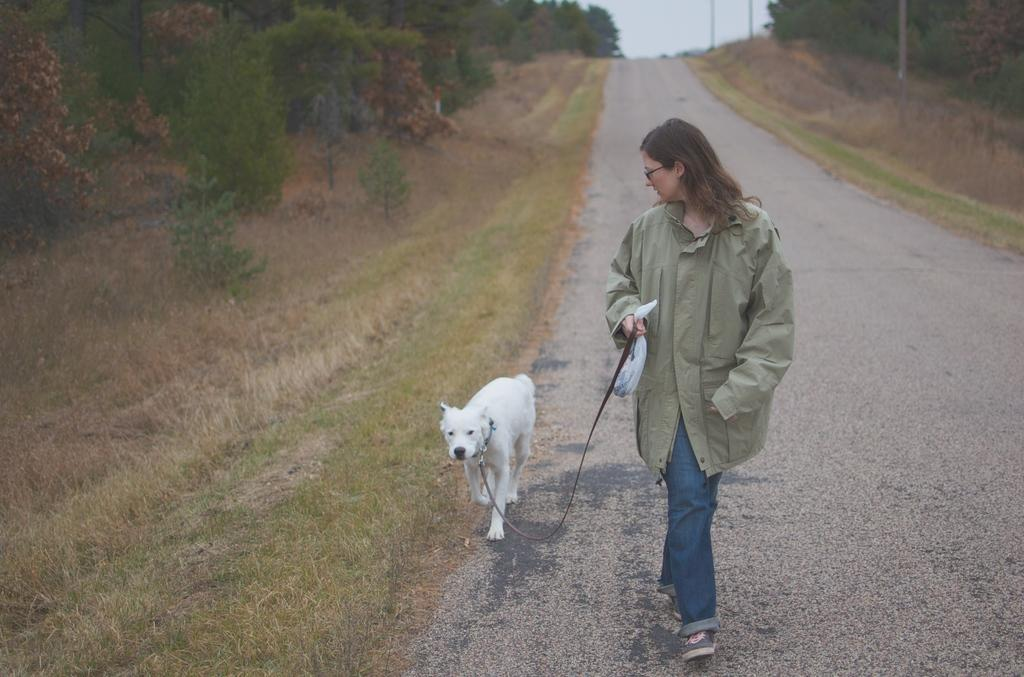What is the woman in the image doing? The woman is walking on the road in the image. Is there any animal accompanying the woman? Yes, there is a dog beside the woman. What can be seen on both sides of the road in the image? There are trees on the left side and right side of the image. What is visible in the background of the image? The sky is visible in the background of the image. What type of cactus can be seen in the image? There is no cactus present in the image. What kind of battle is taking place in the image? There is no battle depicted in the image; it shows a woman walking with a dog. 